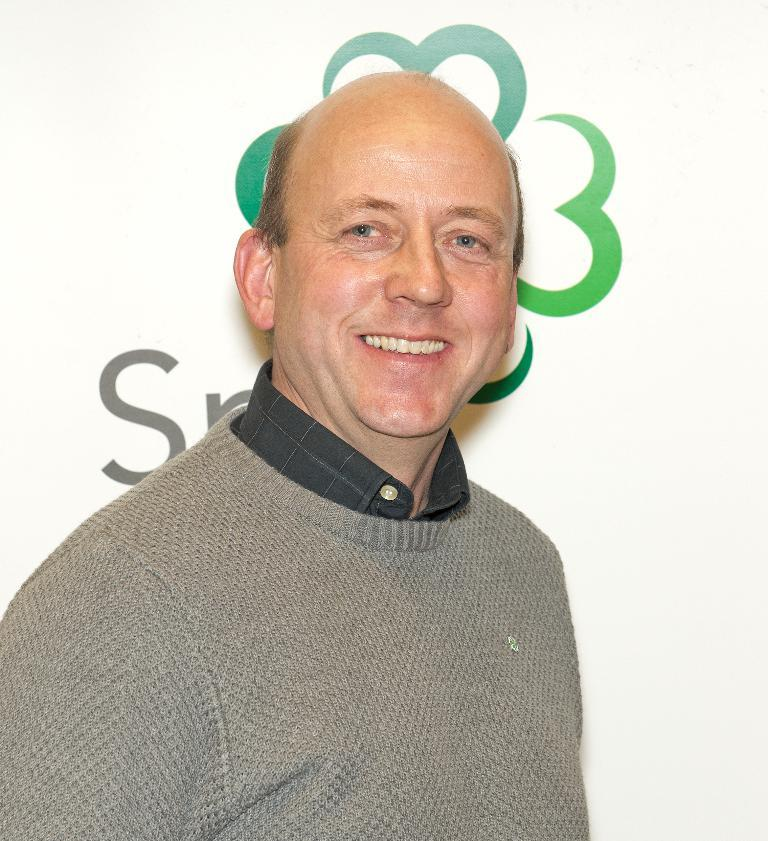Who is present in the image? There is a man in the image. What is the man wearing? The man is wearing a gray T-shirt. What can be seen in the background of the image? There is a banner in the background of the image. What type of magic is the man performing in the image? There is no indication of magic or any magical activity in the image. 